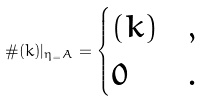Convert formula to latex. <formula><loc_0><loc_0><loc_500><loc_500>\# ( k ) | _ { \eta _ { = } A } = \begin{cases} ( k ) & , \\ 0 & . \end{cases}</formula> 